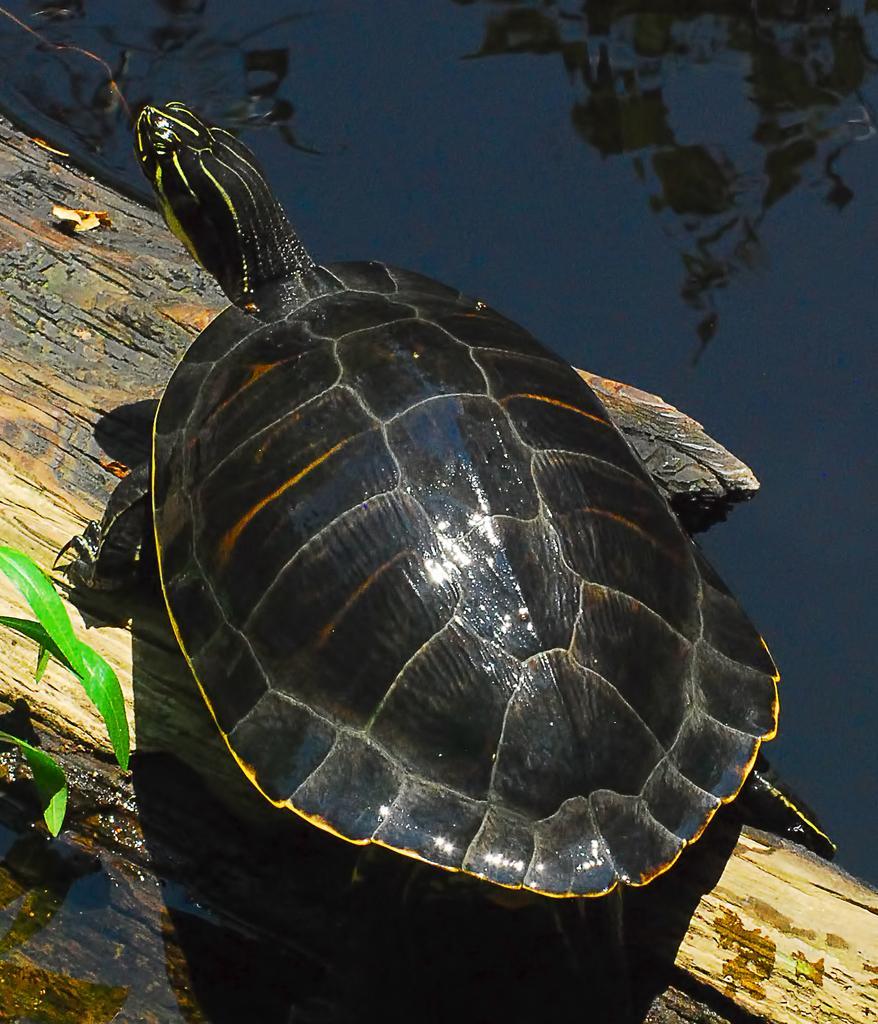In one or two sentences, can you explain what this image depicts? In this image we can see a turtle on the wooden surface. We can also see some leaves and the water. 